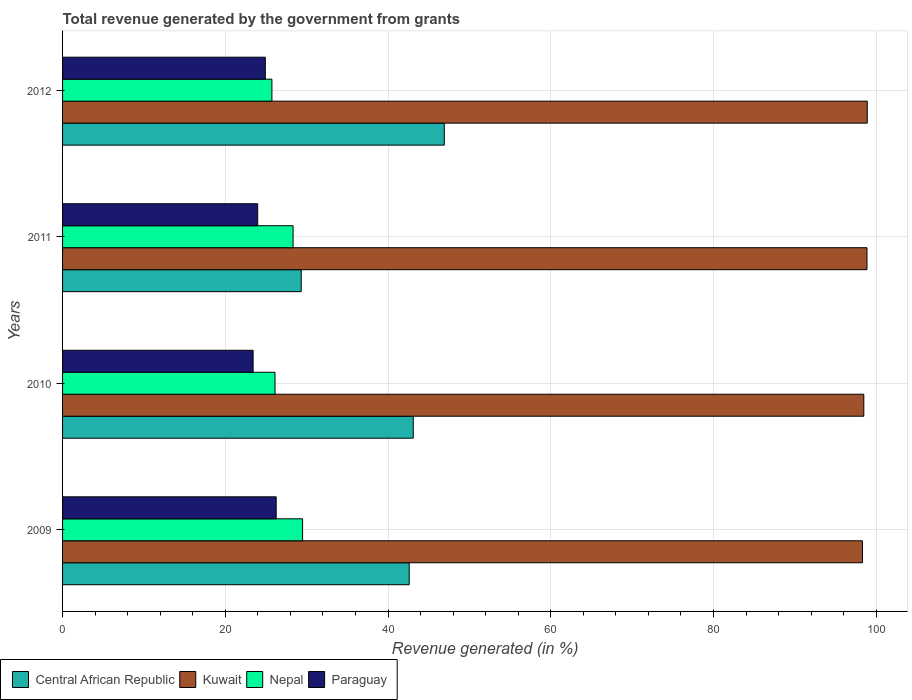How many groups of bars are there?
Your answer should be compact. 4. How many bars are there on the 3rd tick from the top?
Ensure brevity in your answer.  4. What is the total revenue generated in Nepal in 2012?
Ensure brevity in your answer.  25.73. Across all years, what is the maximum total revenue generated in Central African Republic?
Your answer should be compact. 46.91. Across all years, what is the minimum total revenue generated in Kuwait?
Provide a succinct answer. 98.31. In which year was the total revenue generated in Paraguay minimum?
Make the answer very short. 2010. What is the total total revenue generated in Kuwait in the graph?
Provide a short and direct response. 394.54. What is the difference between the total revenue generated in Central African Republic in 2010 and that in 2012?
Provide a short and direct response. -3.82. What is the difference between the total revenue generated in Nepal in 2010 and the total revenue generated in Paraguay in 2012?
Ensure brevity in your answer.  1.19. What is the average total revenue generated in Nepal per year?
Make the answer very short. 27.42. In the year 2009, what is the difference between the total revenue generated in Nepal and total revenue generated in Central African Republic?
Ensure brevity in your answer.  -13.1. What is the ratio of the total revenue generated in Nepal in 2010 to that in 2011?
Offer a terse response. 0.92. Is the difference between the total revenue generated in Nepal in 2009 and 2010 greater than the difference between the total revenue generated in Central African Republic in 2009 and 2010?
Your answer should be very brief. Yes. What is the difference between the highest and the second highest total revenue generated in Kuwait?
Keep it short and to the point. 0.03. What is the difference between the highest and the lowest total revenue generated in Paraguay?
Give a very brief answer. 2.84. In how many years, is the total revenue generated in Nepal greater than the average total revenue generated in Nepal taken over all years?
Keep it short and to the point. 2. Is it the case that in every year, the sum of the total revenue generated in Kuwait and total revenue generated in Nepal is greater than the sum of total revenue generated in Paraguay and total revenue generated in Central African Republic?
Your response must be concise. Yes. What does the 3rd bar from the top in 2012 represents?
Offer a very short reply. Kuwait. What does the 4th bar from the bottom in 2012 represents?
Provide a succinct answer. Paraguay. Is it the case that in every year, the sum of the total revenue generated in Nepal and total revenue generated in Central African Republic is greater than the total revenue generated in Paraguay?
Your answer should be very brief. Yes. Are all the bars in the graph horizontal?
Your answer should be compact. Yes. How many years are there in the graph?
Keep it short and to the point. 4. What is the difference between two consecutive major ticks on the X-axis?
Provide a succinct answer. 20. Does the graph contain grids?
Make the answer very short. Yes. Where does the legend appear in the graph?
Give a very brief answer. Bottom left. How are the legend labels stacked?
Offer a terse response. Horizontal. What is the title of the graph?
Ensure brevity in your answer.  Total revenue generated by the government from grants. Does "Northern Mariana Islands" appear as one of the legend labels in the graph?
Your answer should be compact. No. What is the label or title of the X-axis?
Make the answer very short. Revenue generated (in %). What is the label or title of the Y-axis?
Your answer should be compact. Years. What is the Revenue generated (in %) of Central African Republic in 2009?
Your answer should be compact. 42.6. What is the Revenue generated (in %) in Kuwait in 2009?
Give a very brief answer. 98.31. What is the Revenue generated (in %) of Nepal in 2009?
Your response must be concise. 29.5. What is the Revenue generated (in %) in Paraguay in 2009?
Your answer should be very brief. 26.25. What is the Revenue generated (in %) in Central African Republic in 2010?
Provide a succinct answer. 43.1. What is the Revenue generated (in %) of Kuwait in 2010?
Provide a short and direct response. 98.47. What is the Revenue generated (in %) of Nepal in 2010?
Your answer should be compact. 26.11. What is the Revenue generated (in %) of Paraguay in 2010?
Make the answer very short. 23.42. What is the Revenue generated (in %) in Central African Republic in 2011?
Provide a short and direct response. 29.33. What is the Revenue generated (in %) of Kuwait in 2011?
Your answer should be very brief. 98.86. What is the Revenue generated (in %) in Nepal in 2011?
Keep it short and to the point. 28.33. What is the Revenue generated (in %) in Paraguay in 2011?
Offer a very short reply. 23.98. What is the Revenue generated (in %) of Central African Republic in 2012?
Your answer should be very brief. 46.91. What is the Revenue generated (in %) in Kuwait in 2012?
Your answer should be compact. 98.9. What is the Revenue generated (in %) in Nepal in 2012?
Give a very brief answer. 25.73. What is the Revenue generated (in %) of Paraguay in 2012?
Ensure brevity in your answer.  24.92. Across all years, what is the maximum Revenue generated (in %) of Central African Republic?
Provide a succinct answer. 46.91. Across all years, what is the maximum Revenue generated (in %) in Kuwait?
Your answer should be very brief. 98.9. Across all years, what is the maximum Revenue generated (in %) in Nepal?
Keep it short and to the point. 29.5. Across all years, what is the maximum Revenue generated (in %) in Paraguay?
Give a very brief answer. 26.25. Across all years, what is the minimum Revenue generated (in %) of Central African Republic?
Your response must be concise. 29.33. Across all years, what is the minimum Revenue generated (in %) of Kuwait?
Ensure brevity in your answer.  98.31. Across all years, what is the minimum Revenue generated (in %) in Nepal?
Your answer should be compact. 25.73. Across all years, what is the minimum Revenue generated (in %) in Paraguay?
Your answer should be very brief. 23.42. What is the total Revenue generated (in %) of Central African Republic in the graph?
Your answer should be very brief. 161.94. What is the total Revenue generated (in %) of Kuwait in the graph?
Provide a succinct answer. 394.54. What is the total Revenue generated (in %) in Nepal in the graph?
Your answer should be compact. 109.67. What is the total Revenue generated (in %) in Paraguay in the graph?
Provide a succinct answer. 98.57. What is the difference between the Revenue generated (in %) of Central African Republic in 2009 and that in 2010?
Provide a succinct answer. -0.5. What is the difference between the Revenue generated (in %) in Kuwait in 2009 and that in 2010?
Give a very brief answer. -0.17. What is the difference between the Revenue generated (in %) in Nepal in 2009 and that in 2010?
Your answer should be compact. 3.39. What is the difference between the Revenue generated (in %) in Paraguay in 2009 and that in 2010?
Make the answer very short. 2.84. What is the difference between the Revenue generated (in %) of Central African Republic in 2009 and that in 2011?
Your answer should be compact. 13.27. What is the difference between the Revenue generated (in %) of Kuwait in 2009 and that in 2011?
Provide a succinct answer. -0.56. What is the difference between the Revenue generated (in %) in Nepal in 2009 and that in 2011?
Offer a terse response. 1.17. What is the difference between the Revenue generated (in %) in Paraguay in 2009 and that in 2011?
Keep it short and to the point. 2.27. What is the difference between the Revenue generated (in %) of Central African Republic in 2009 and that in 2012?
Your response must be concise. -4.31. What is the difference between the Revenue generated (in %) in Kuwait in 2009 and that in 2012?
Give a very brief answer. -0.59. What is the difference between the Revenue generated (in %) in Nepal in 2009 and that in 2012?
Offer a very short reply. 3.77. What is the difference between the Revenue generated (in %) of Paraguay in 2009 and that in 2012?
Keep it short and to the point. 1.34. What is the difference between the Revenue generated (in %) of Central African Republic in 2010 and that in 2011?
Your response must be concise. 13.77. What is the difference between the Revenue generated (in %) of Kuwait in 2010 and that in 2011?
Your response must be concise. -0.39. What is the difference between the Revenue generated (in %) of Nepal in 2010 and that in 2011?
Provide a succinct answer. -2.22. What is the difference between the Revenue generated (in %) of Paraguay in 2010 and that in 2011?
Make the answer very short. -0.56. What is the difference between the Revenue generated (in %) of Central African Republic in 2010 and that in 2012?
Give a very brief answer. -3.82. What is the difference between the Revenue generated (in %) of Kuwait in 2010 and that in 2012?
Offer a very short reply. -0.42. What is the difference between the Revenue generated (in %) in Nepal in 2010 and that in 2012?
Provide a short and direct response. 0.38. What is the difference between the Revenue generated (in %) in Paraguay in 2010 and that in 2012?
Your response must be concise. -1.5. What is the difference between the Revenue generated (in %) of Central African Republic in 2011 and that in 2012?
Offer a very short reply. -17.58. What is the difference between the Revenue generated (in %) of Kuwait in 2011 and that in 2012?
Keep it short and to the point. -0.03. What is the difference between the Revenue generated (in %) of Nepal in 2011 and that in 2012?
Your answer should be very brief. 2.6. What is the difference between the Revenue generated (in %) in Paraguay in 2011 and that in 2012?
Your answer should be compact. -0.94. What is the difference between the Revenue generated (in %) of Central African Republic in 2009 and the Revenue generated (in %) of Kuwait in 2010?
Your response must be concise. -55.87. What is the difference between the Revenue generated (in %) in Central African Republic in 2009 and the Revenue generated (in %) in Nepal in 2010?
Make the answer very short. 16.49. What is the difference between the Revenue generated (in %) in Central African Republic in 2009 and the Revenue generated (in %) in Paraguay in 2010?
Your answer should be very brief. 19.18. What is the difference between the Revenue generated (in %) of Kuwait in 2009 and the Revenue generated (in %) of Nepal in 2010?
Your response must be concise. 72.2. What is the difference between the Revenue generated (in %) in Kuwait in 2009 and the Revenue generated (in %) in Paraguay in 2010?
Offer a very short reply. 74.89. What is the difference between the Revenue generated (in %) in Nepal in 2009 and the Revenue generated (in %) in Paraguay in 2010?
Your answer should be compact. 6.08. What is the difference between the Revenue generated (in %) of Central African Republic in 2009 and the Revenue generated (in %) of Kuwait in 2011?
Make the answer very short. -56.26. What is the difference between the Revenue generated (in %) of Central African Republic in 2009 and the Revenue generated (in %) of Nepal in 2011?
Offer a terse response. 14.27. What is the difference between the Revenue generated (in %) in Central African Republic in 2009 and the Revenue generated (in %) in Paraguay in 2011?
Give a very brief answer. 18.62. What is the difference between the Revenue generated (in %) in Kuwait in 2009 and the Revenue generated (in %) in Nepal in 2011?
Your answer should be compact. 69.97. What is the difference between the Revenue generated (in %) of Kuwait in 2009 and the Revenue generated (in %) of Paraguay in 2011?
Your answer should be very brief. 74.33. What is the difference between the Revenue generated (in %) of Nepal in 2009 and the Revenue generated (in %) of Paraguay in 2011?
Offer a terse response. 5.52. What is the difference between the Revenue generated (in %) in Central African Republic in 2009 and the Revenue generated (in %) in Kuwait in 2012?
Provide a short and direct response. -56.3. What is the difference between the Revenue generated (in %) in Central African Republic in 2009 and the Revenue generated (in %) in Nepal in 2012?
Offer a terse response. 16.87. What is the difference between the Revenue generated (in %) in Central African Republic in 2009 and the Revenue generated (in %) in Paraguay in 2012?
Your answer should be compact. 17.68. What is the difference between the Revenue generated (in %) of Kuwait in 2009 and the Revenue generated (in %) of Nepal in 2012?
Provide a short and direct response. 72.58. What is the difference between the Revenue generated (in %) in Kuwait in 2009 and the Revenue generated (in %) in Paraguay in 2012?
Provide a short and direct response. 73.39. What is the difference between the Revenue generated (in %) in Nepal in 2009 and the Revenue generated (in %) in Paraguay in 2012?
Provide a short and direct response. 4.58. What is the difference between the Revenue generated (in %) of Central African Republic in 2010 and the Revenue generated (in %) of Kuwait in 2011?
Keep it short and to the point. -55.77. What is the difference between the Revenue generated (in %) of Central African Republic in 2010 and the Revenue generated (in %) of Nepal in 2011?
Give a very brief answer. 14.77. What is the difference between the Revenue generated (in %) in Central African Republic in 2010 and the Revenue generated (in %) in Paraguay in 2011?
Provide a succinct answer. 19.12. What is the difference between the Revenue generated (in %) of Kuwait in 2010 and the Revenue generated (in %) of Nepal in 2011?
Ensure brevity in your answer.  70.14. What is the difference between the Revenue generated (in %) of Kuwait in 2010 and the Revenue generated (in %) of Paraguay in 2011?
Your answer should be very brief. 74.49. What is the difference between the Revenue generated (in %) of Nepal in 2010 and the Revenue generated (in %) of Paraguay in 2011?
Offer a terse response. 2.13. What is the difference between the Revenue generated (in %) of Central African Republic in 2010 and the Revenue generated (in %) of Kuwait in 2012?
Give a very brief answer. -55.8. What is the difference between the Revenue generated (in %) in Central African Republic in 2010 and the Revenue generated (in %) in Nepal in 2012?
Provide a short and direct response. 17.37. What is the difference between the Revenue generated (in %) of Central African Republic in 2010 and the Revenue generated (in %) of Paraguay in 2012?
Provide a short and direct response. 18.18. What is the difference between the Revenue generated (in %) in Kuwait in 2010 and the Revenue generated (in %) in Nepal in 2012?
Ensure brevity in your answer.  72.75. What is the difference between the Revenue generated (in %) of Kuwait in 2010 and the Revenue generated (in %) of Paraguay in 2012?
Your response must be concise. 73.56. What is the difference between the Revenue generated (in %) of Nepal in 2010 and the Revenue generated (in %) of Paraguay in 2012?
Your answer should be very brief. 1.19. What is the difference between the Revenue generated (in %) in Central African Republic in 2011 and the Revenue generated (in %) in Kuwait in 2012?
Offer a very short reply. -69.57. What is the difference between the Revenue generated (in %) in Central African Republic in 2011 and the Revenue generated (in %) in Nepal in 2012?
Your answer should be very brief. 3.6. What is the difference between the Revenue generated (in %) of Central African Republic in 2011 and the Revenue generated (in %) of Paraguay in 2012?
Give a very brief answer. 4.41. What is the difference between the Revenue generated (in %) in Kuwait in 2011 and the Revenue generated (in %) in Nepal in 2012?
Offer a very short reply. 73.14. What is the difference between the Revenue generated (in %) of Kuwait in 2011 and the Revenue generated (in %) of Paraguay in 2012?
Offer a terse response. 73.95. What is the difference between the Revenue generated (in %) in Nepal in 2011 and the Revenue generated (in %) in Paraguay in 2012?
Your answer should be very brief. 3.41. What is the average Revenue generated (in %) in Central African Republic per year?
Offer a very short reply. 40.49. What is the average Revenue generated (in %) in Kuwait per year?
Your answer should be very brief. 98.64. What is the average Revenue generated (in %) in Nepal per year?
Your response must be concise. 27.42. What is the average Revenue generated (in %) in Paraguay per year?
Offer a terse response. 24.64. In the year 2009, what is the difference between the Revenue generated (in %) in Central African Republic and Revenue generated (in %) in Kuwait?
Keep it short and to the point. -55.71. In the year 2009, what is the difference between the Revenue generated (in %) of Central African Republic and Revenue generated (in %) of Nepal?
Provide a short and direct response. 13.1. In the year 2009, what is the difference between the Revenue generated (in %) in Central African Republic and Revenue generated (in %) in Paraguay?
Ensure brevity in your answer.  16.35. In the year 2009, what is the difference between the Revenue generated (in %) in Kuwait and Revenue generated (in %) in Nepal?
Make the answer very short. 68.81. In the year 2009, what is the difference between the Revenue generated (in %) in Kuwait and Revenue generated (in %) in Paraguay?
Your response must be concise. 72.05. In the year 2009, what is the difference between the Revenue generated (in %) of Nepal and Revenue generated (in %) of Paraguay?
Make the answer very short. 3.24. In the year 2010, what is the difference between the Revenue generated (in %) of Central African Republic and Revenue generated (in %) of Kuwait?
Provide a succinct answer. -55.38. In the year 2010, what is the difference between the Revenue generated (in %) in Central African Republic and Revenue generated (in %) in Nepal?
Keep it short and to the point. 16.99. In the year 2010, what is the difference between the Revenue generated (in %) of Central African Republic and Revenue generated (in %) of Paraguay?
Your response must be concise. 19.68. In the year 2010, what is the difference between the Revenue generated (in %) in Kuwait and Revenue generated (in %) in Nepal?
Offer a very short reply. 72.36. In the year 2010, what is the difference between the Revenue generated (in %) of Kuwait and Revenue generated (in %) of Paraguay?
Offer a very short reply. 75.06. In the year 2010, what is the difference between the Revenue generated (in %) in Nepal and Revenue generated (in %) in Paraguay?
Your answer should be very brief. 2.69. In the year 2011, what is the difference between the Revenue generated (in %) of Central African Republic and Revenue generated (in %) of Kuwait?
Ensure brevity in your answer.  -69.53. In the year 2011, what is the difference between the Revenue generated (in %) of Central African Republic and Revenue generated (in %) of Paraguay?
Offer a terse response. 5.35. In the year 2011, what is the difference between the Revenue generated (in %) of Kuwait and Revenue generated (in %) of Nepal?
Make the answer very short. 70.53. In the year 2011, what is the difference between the Revenue generated (in %) in Kuwait and Revenue generated (in %) in Paraguay?
Your answer should be very brief. 74.88. In the year 2011, what is the difference between the Revenue generated (in %) in Nepal and Revenue generated (in %) in Paraguay?
Keep it short and to the point. 4.35. In the year 2012, what is the difference between the Revenue generated (in %) of Central African Republic and Revenue generated (in %) of Kuwait?
Offer a terse response. -51.98. In the year 2012, what is the difference between the Revenue generated (in %) in Central African Republic and Revenue generated (in %) in Nepal?
Offer a very short reply. 21.19. In the year 2012, what is the difference between the Revenue generated (in %) of Central African Republic and Revenue generated (in %) of Paraguay?
Provide a succinct answer. 22. In the year 2012, what is the difference between the Revenue generated (in %) of Kuwait and Revenue generated (in %) of Nepal?
Provide a short and direct response. 73.17. In the year 2012, what is the difference between the Revenue generated (in %) in Kuwait and Revenue generated (in %) in Paraguay?
Offer a terse response. 73.98. In the year 2012, what is the difference between the Revenue generated (in %) in Nepal and Revenue generated (in %) in Paraguay?
Offer a very short reply. 0.81. What is the ratio of the Revenue generated (in %) of Central African Republic in 2009 to that in 2010?
Provide a succinct answer. 0.99. What is the ratio of the Revenue generated (in %) of Nepal in 2009 to that in 2010?
Provide a succinct answer. 1.13. What is the ratio of the Revenue generated (in %) of Paraguay in 2009 to that in 2010?
Your answer should be compact. 1.12. What is the ratio of the Revenue generated (in %) of Central African Republic in 2009 to that in 2011?
Your answer should be very brief. 1.45. What is the ratio of the Revenue generated (in %) of Kuwait in 2009 to that in 2011?
Your answer should be compact. 0.99. What is the ratio of the Revenue generated (in %) in Nepal in 2009 to that in 2011?
Make the answer very short. 1.04. What is the ratio of the Revenue generated (in %) of Paraguay in 2009 to that in 2011?
Your answer should be compact. 1.09. What is the ratio of the Revenue generated (in %) in Central African Republic in 2009 to that in 2012?
Keep it short and to the point. 0.91. What is the ratio of the Revenue generated (in %) in Nepal in 2009 to that in 2012?
Give a very brief answer. 1.15. What is the ratio of the Revenue generated (in %) in Paraguay in 2009 to that in 2012?
Your response must be concise. 1.05. What is the ratio of the Revenue generated (in %) in Central African Republic in 2010 to that in 2011?
Your response must be concise. 1.47. What is the ratio of the Revenue generated (in %) of Kuwait in 2010 to that in 2011?
Provide a short and direct response. 1. What is the ratio of the Revenue generated (in %) in Nepal in 2010 to that in 2011?
Your answer should be very brief. 0.92. What is the ratio of the Revenue generated (in %) of Paraguay in 2010 to that in 2011?
Your answer should be very brief. 0.98. What is the ratio of the Revenue generated (in %) in Central African Republic in 2010 to that in 2012?
Make the answer very short. 0.92. What is the ratio of the Revenue generated (in %) of Nepal in 2010 to that in 2012?
Ensure brevity in your answer.  1.01. What is the ratio of the Revenue generated (in %) of Paraguay in 2010 to that in 2012?
Your response must be concise. 0.94. What is the ratio of the Revenue generated (in %) of Central African Republic in 2011 to that in 2012?
Your answer should be compact. 0.63. What is the ratio of the Revenue generated (in %) of Kuwait in 2011 to that in 2012?
Offer a very short reply. 1. What is the ratio of the Revenue generated (in %) of Nepal in 2011 to that in 2012?
Make the answer very short. 1.1. What is the ratio of the Revenue generated (in %) in Paraguay in 2011 to that in 2012?
Provide a short and direct response. 0.96. What is the difference between the highest and the second highest Revenue generated (in %) of Central African Republic?
Ensure brevity in your answer.  3.82. What is the difference between the highest and the second highest Revenue generated (in %) of Kuwait?
Ensure brevity in your answer.  0.03. What is the difference between the highest and the second highest Revenue generated (in %) of Nepal?
Your answer should be very brief. 1.17. What is the difference between the highest and the second highest Revenue generated (in %) of Paraguay?
Offer a terse response. 1.34. What is the difference between the highest and the lowest Revenue generated (in %) in Central African Republic?
Provide a short and direct response. 17.58. What is the difference between the highest and the lowest Revenue generated (in %) in Kuwait?
Offer a very short reply. 0.59. What is the difference between the highest and the lowest Revenue generated (in %) of Nepal?
Provide a succinct answer. 3.77. What is the difference between the highest and the lowest Revenue generated (in %) in Paraguay?
Keep it short and to the point. 2.84. 